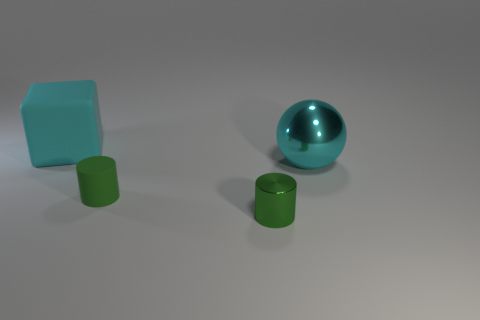Add 2 big cyan matte cubes. How many objects exist? 6 How many green cylinders must be subtracted to get 1 green cylinders? 1 Subtract 2 cylinders. How many cylinders are left? 0 Subtract all brown spheres. Subtract all brown cubes. How many spheres are left? 1 Subtract all blue spheres. How many red cubes are left? 0 Subtract all big purple objects. Subtract all tiny green matte objects. How many objects are left? 3 Add 1 green things. How many green things are left? 3 Add 3 cyan blocks. How many cyan blocks exist? 4 Subtract 0 gray cylinders. How many objects are left? 4 Subtract all cubes. How many objects are left? 3 